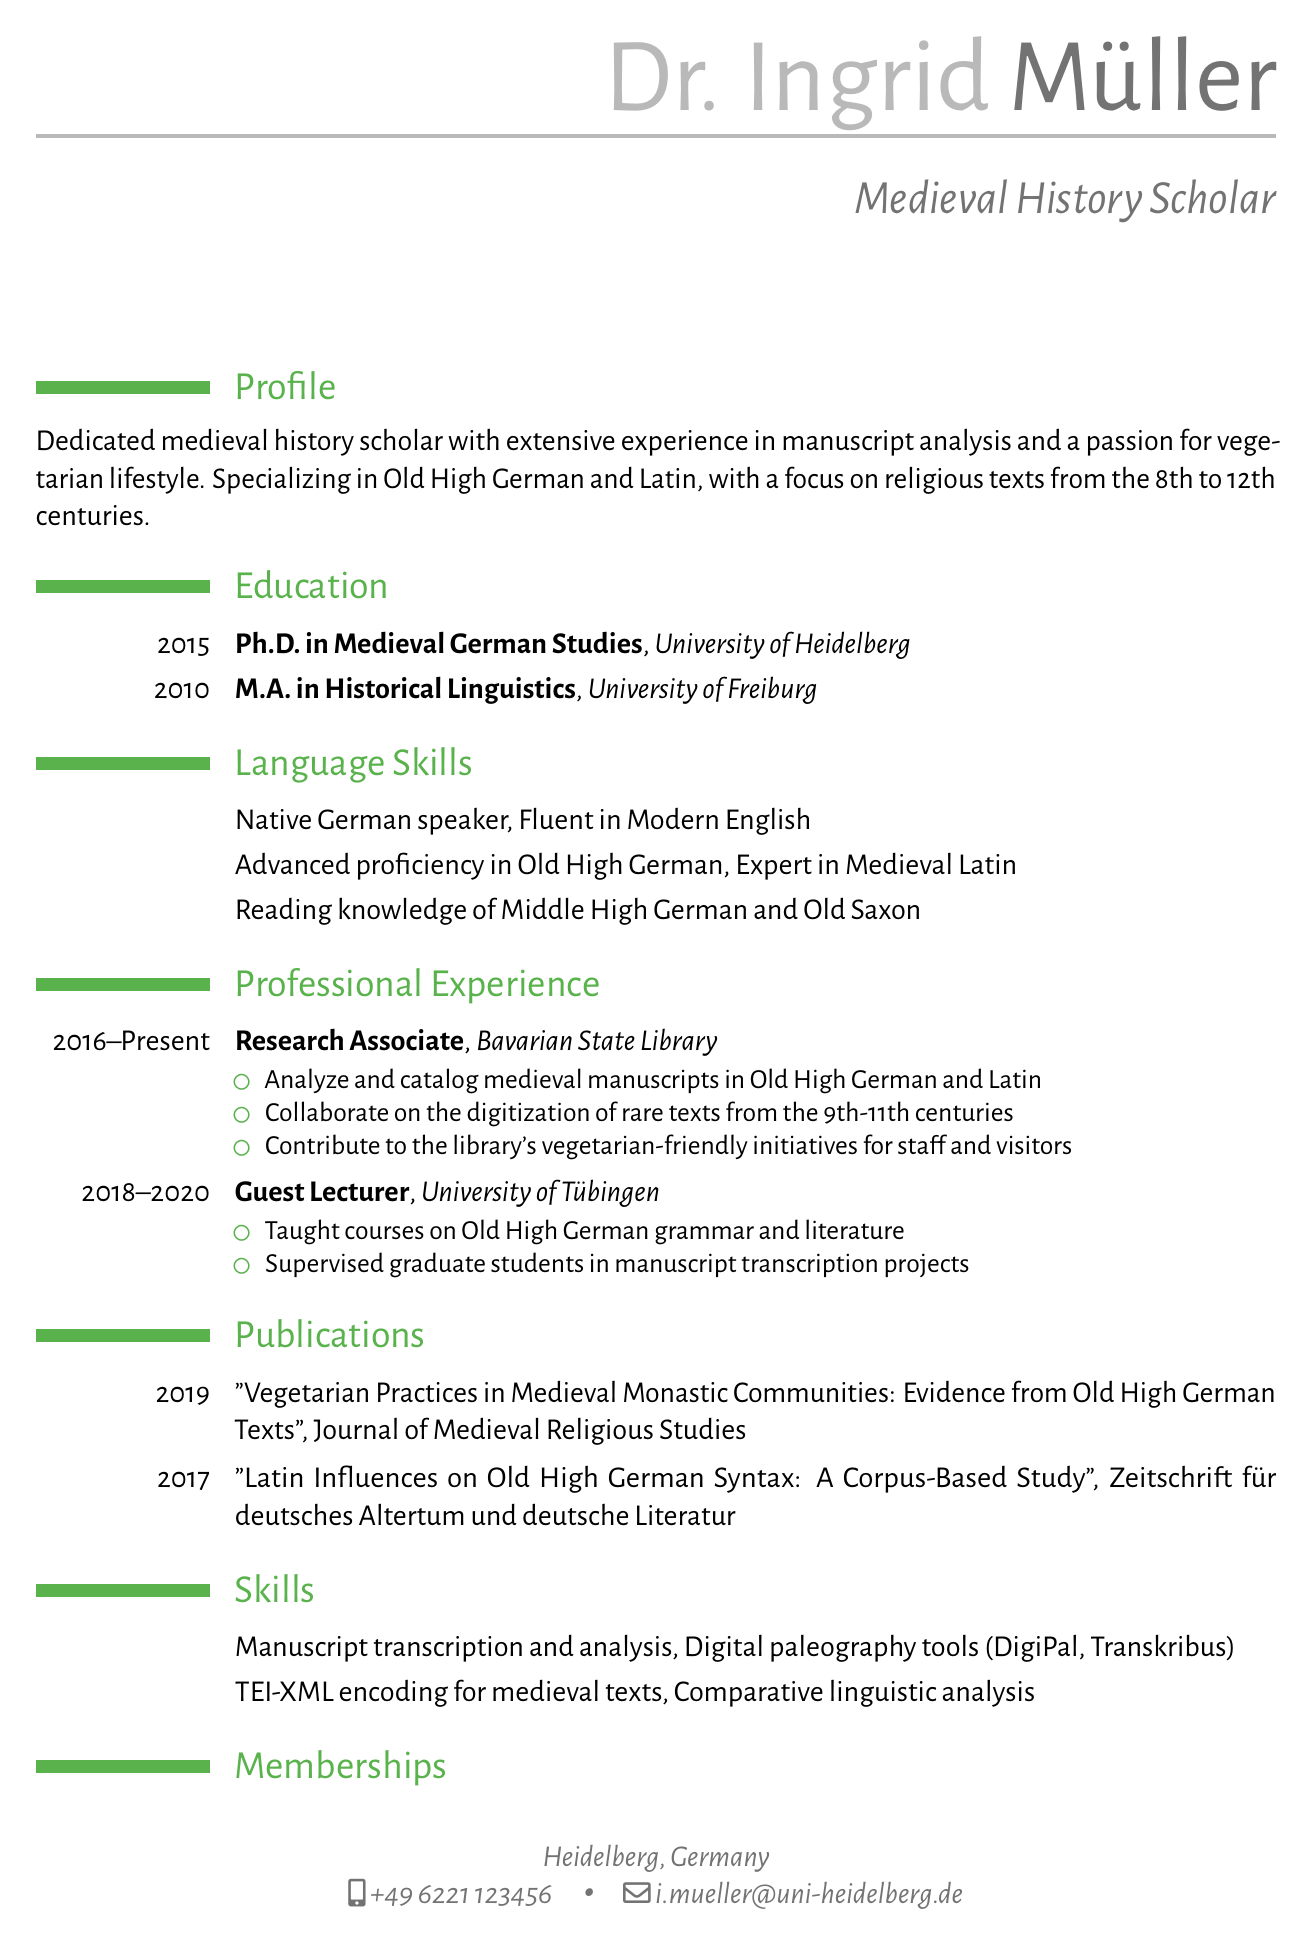what is Dr. Ingrid Müller's email address? The email address listed in the document for Dr. Ingrid Müller is i.mueller@uni-heidelberg.de.
Answer: i.mueller@uni-heidelberg.de what degree did Dr. Ingrid Müller obtain in 2015? According to the education section, Dr. Ingrid Müller obtained a Ph.D. in Medieval German Studies in 2015.
Answer: Ph.D. in Medieval German Studies how many languages is Dr. Müller proficient in? The language skills section lists five language proficiencies for Dr. Müller.
Answer: Five which institution did Dr. Müller work for as a Research Associate? The professional experience section states that Dr. Müller worked as a Research Associate at the Bavarian State Library.
Answer: Bavarian State Library in which journal was Dr. Müller's 2019 publication featured? The publications section indicates that the 2019 publication was featured in the Journal of Medieval Religious Studies.
Answer: Journal of Medieval Religious Studies what was one of Dr. Müller's responsibilities at the University of Tübingen? The document mentions that Dr. Müller taught courses on Old High German grammar and literature at the University of Tübingen.
Answer: Taught courses on Old High German grammar and literature which organization is Dr. Müller a member of that focuses on early medieval studies? The memberships section states that Dr. Müller is a member of the International Society for the Study of Early Medieval England.
Answer: International Society for the Study of Early Medieval England what specific medieval texts does Dr. Müller specialize in? The profile summary indicates that Dr. Müller specializes in Old High German and Latin, specifically religious texts from the 8th to 12th centuries.
Answer: Old High German and Latin, religious texts from the 8th to 12th centuries 